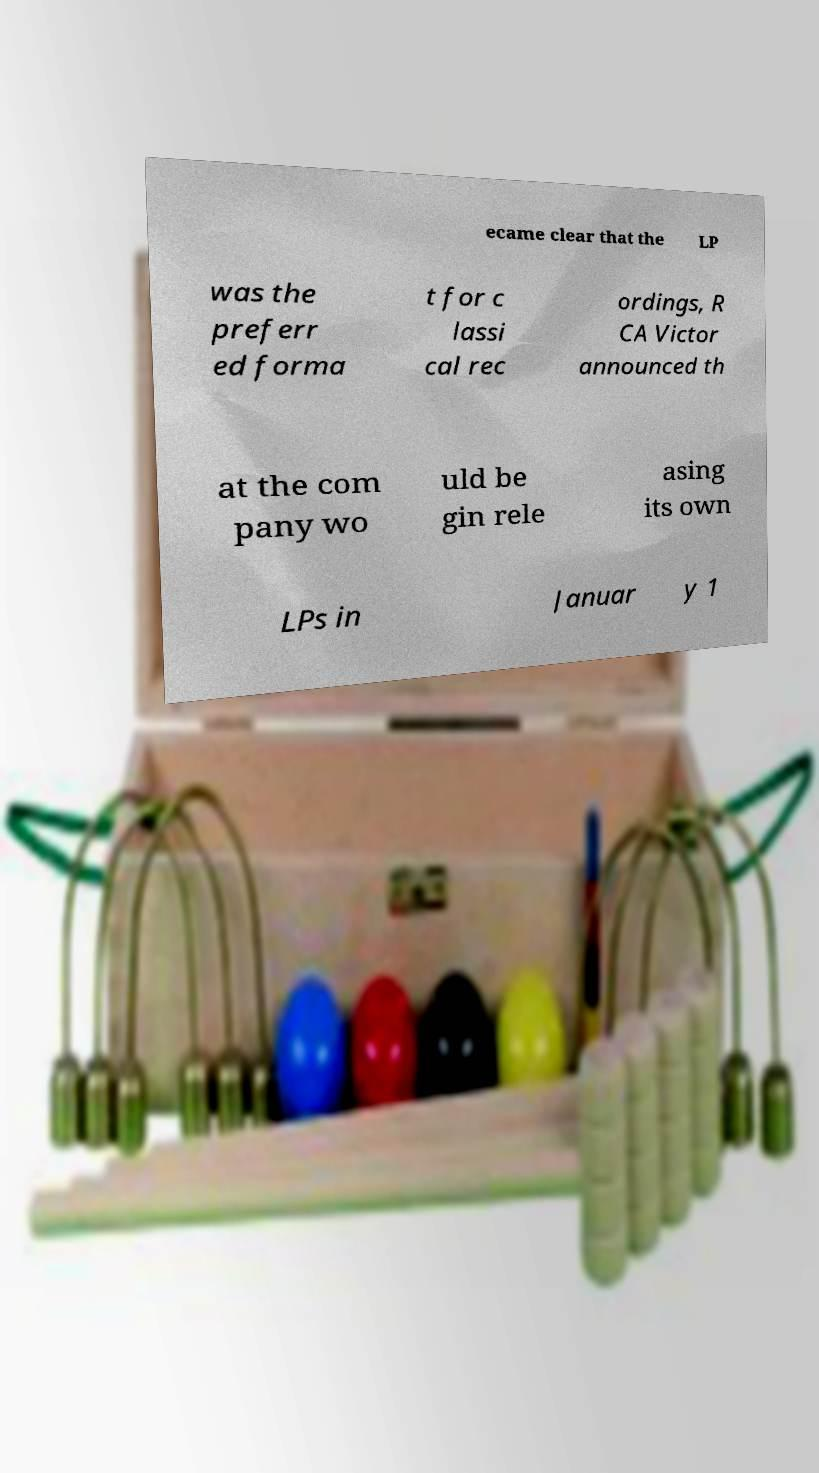Please identify and transcribe the text found in this image. ecame clear that the LP was the preferr ed forma t for c lassi cal rec ordings, R CA Victor announced th at the com pany wo uld be gin rele asing its own LPs in Januar y 1 